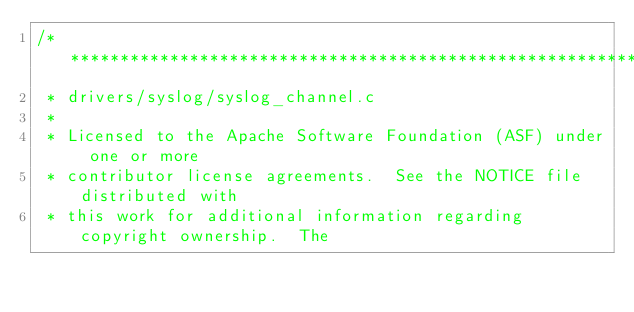Convert code to text. <code><loc_0><loc_0><loc_500><loc_500><_C_>/****************************************************************************
 * drivers/syslog/syslog_channel.c
 *
 * Licensed to the Apache Software Foundation (ASF) under one or more
 * contributor license agreements.  See the NOTICE file distributed with
 * this work for additional information regarding copyright ownership.  The</code> 